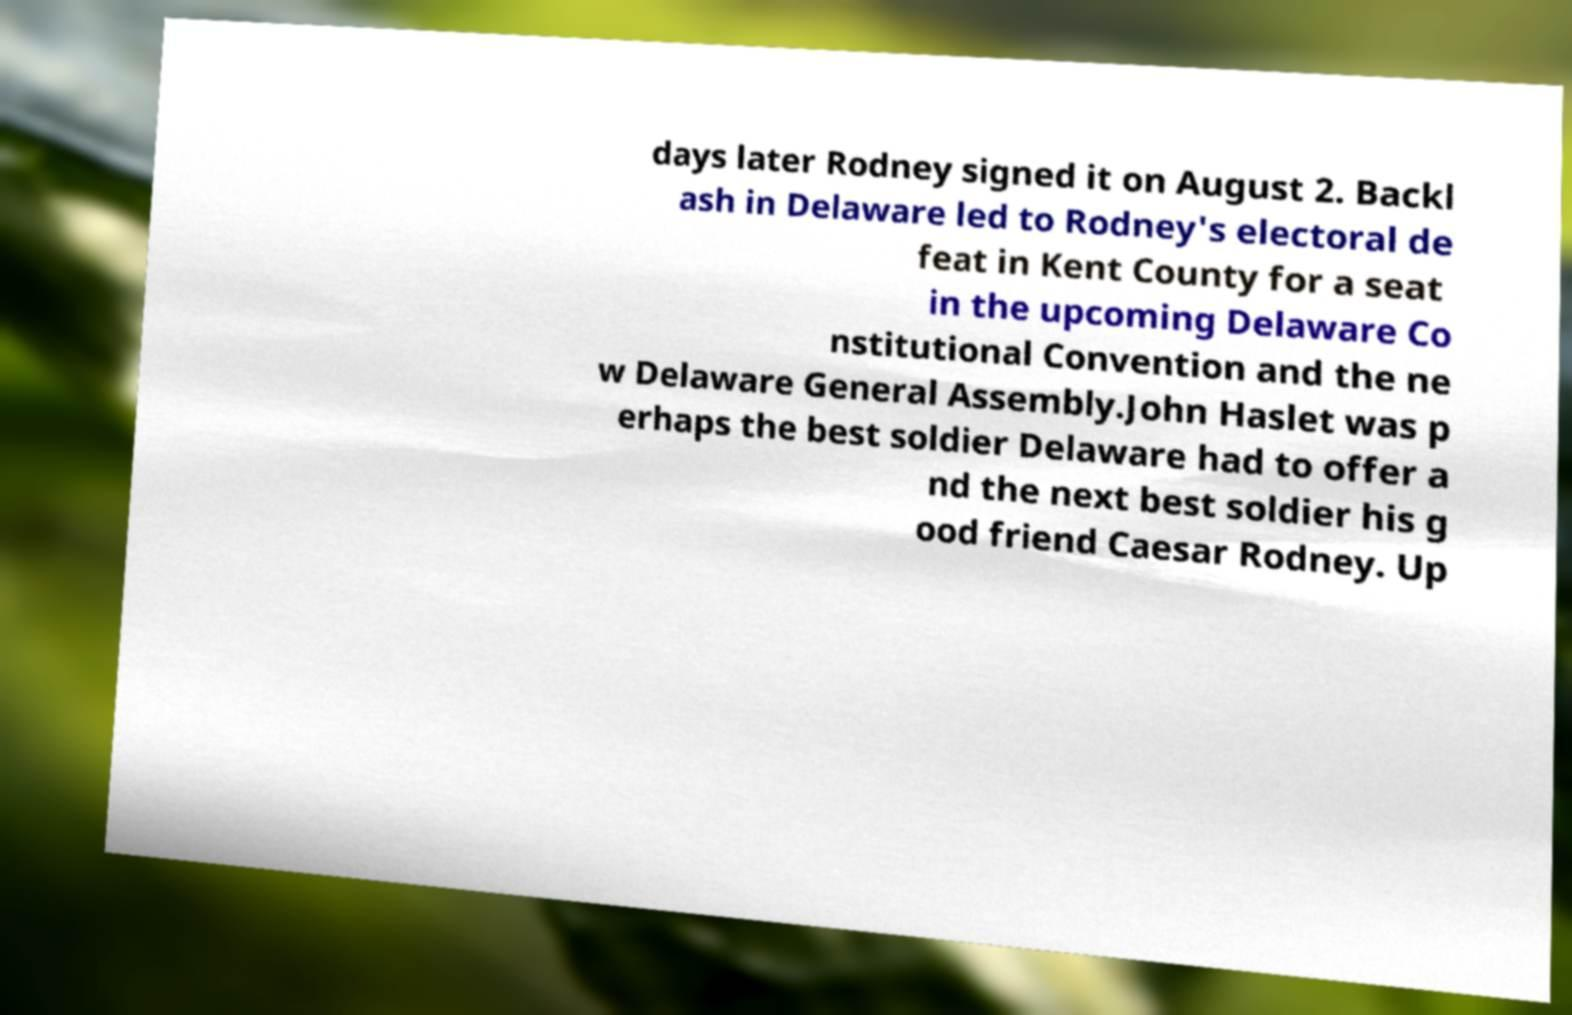Could you extract and type out the text from this image? days later Rodney signed it on August 2. Backl ash in Delaware led to Rodney's electoral de feat in Kent County for a seat in the upcoming Delaware Co nstitutional Convention and the ne w Delaware General Assembly.John Haslet was p erhaps the best soldier Delaware had to offer a nd the next best soldier his g ood friend Caesar Rodney. Up 